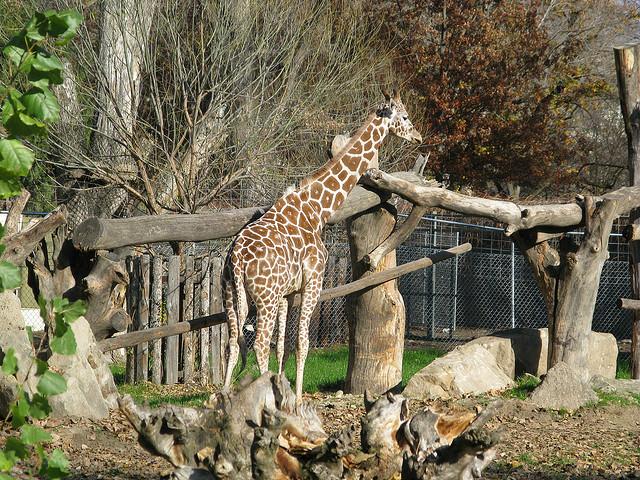Is this in a zoo?
Be succinct. Yes. What is the fence keeping the giraffe in captivity made of?
Short answer required. Wood. Can the giraffe walk under the tree branches if it wants to?
Keep it brief. No. 